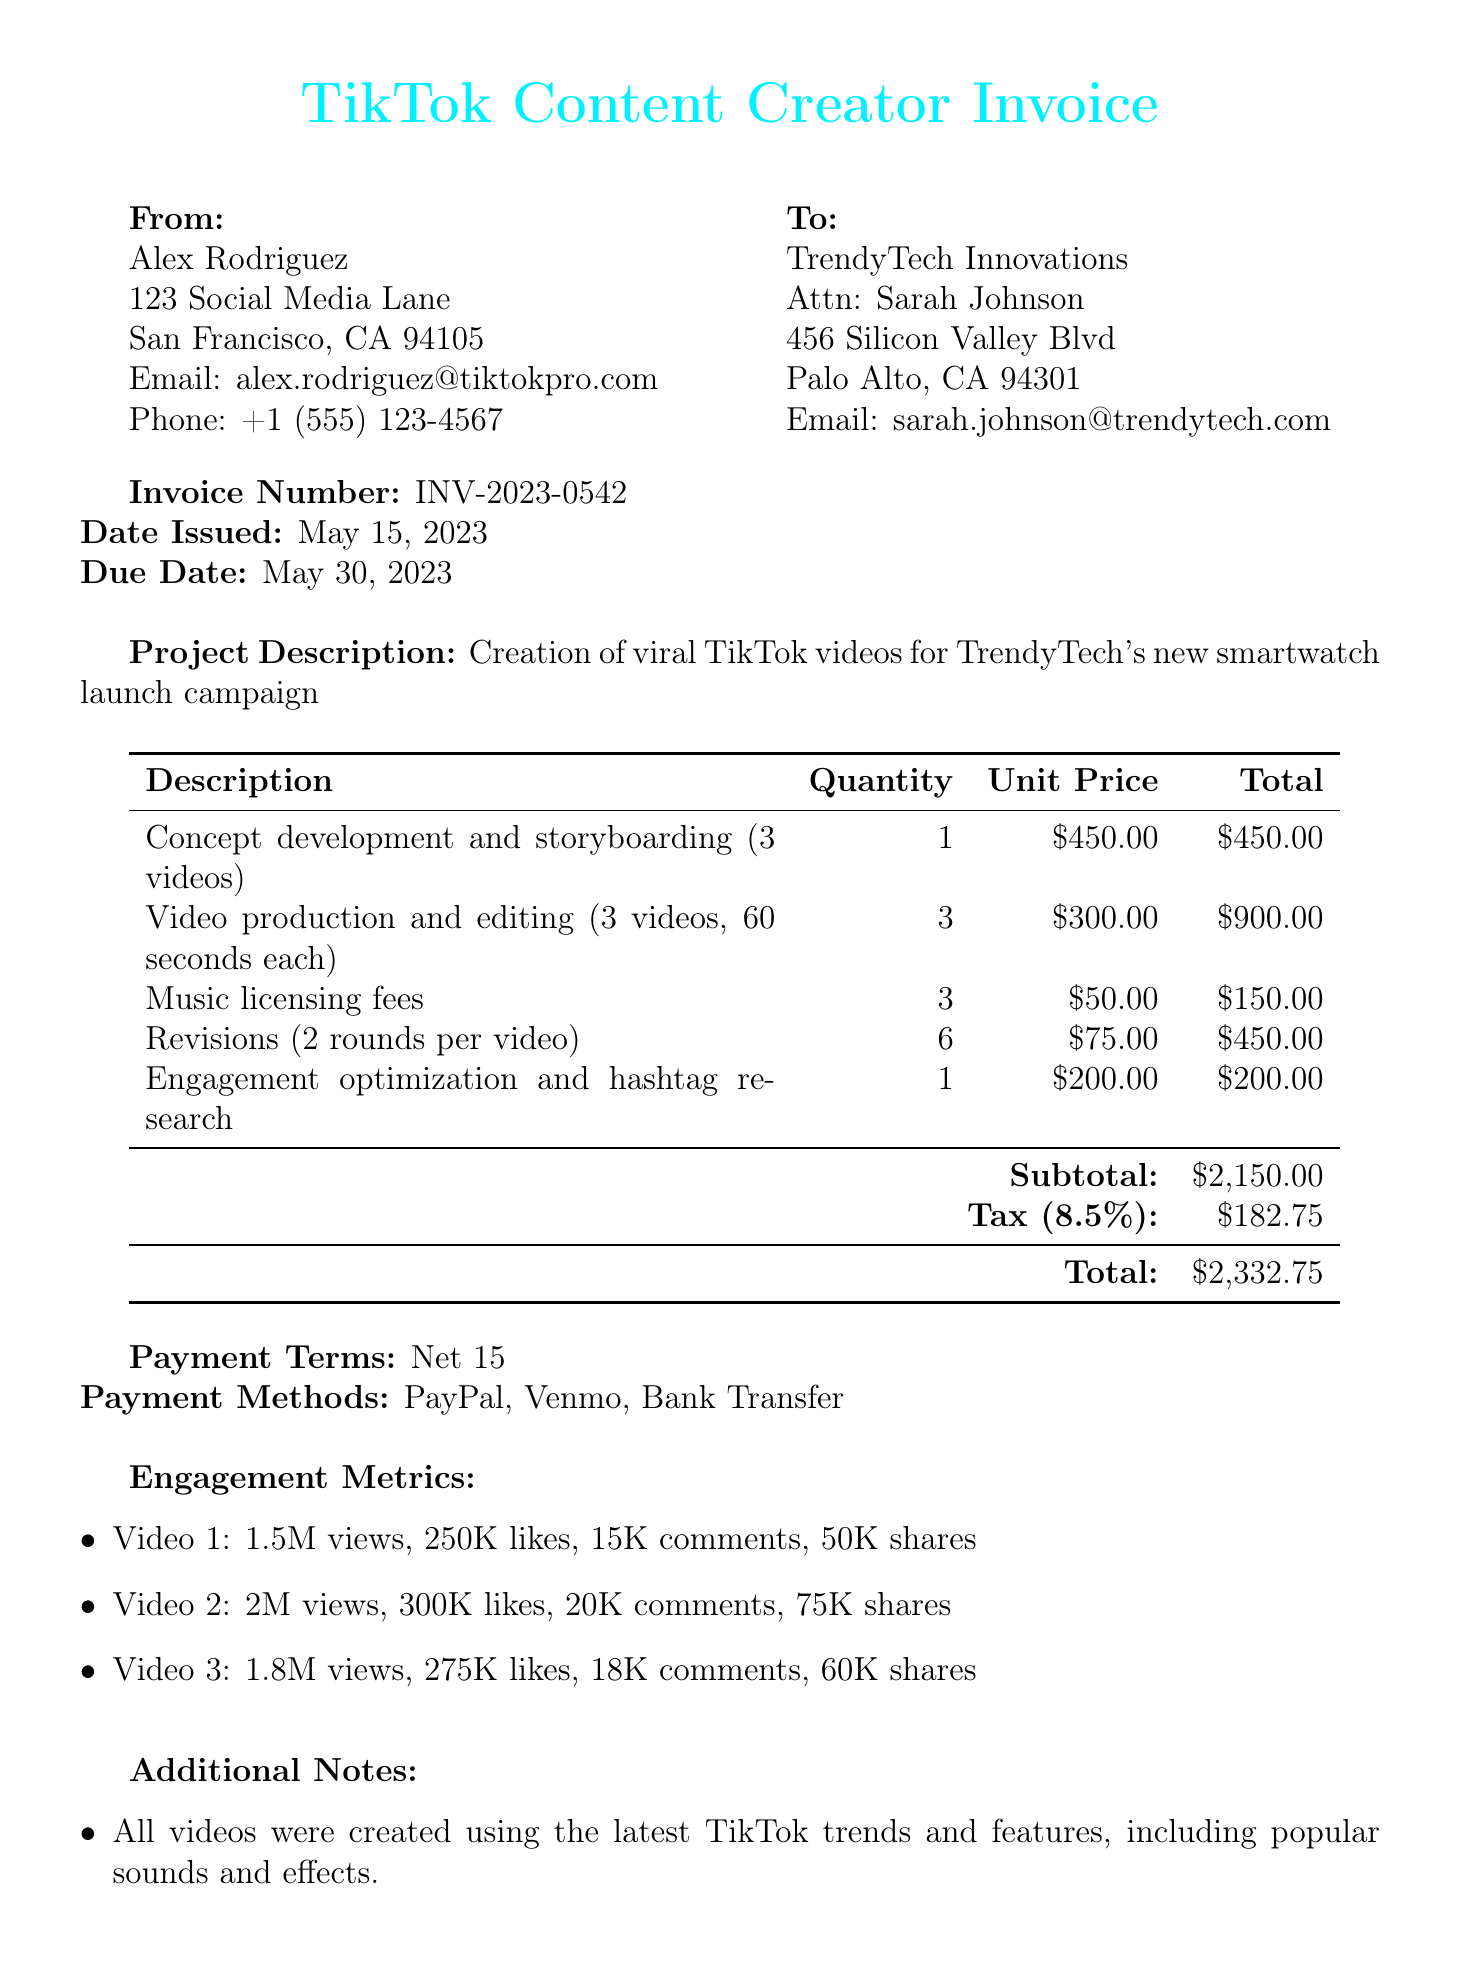What is the invoice number? The invoice number is a unique identifier for the document, which is listed as INV-2023-0542.
Answer: INV-2023-0542 Who is the freelancer? The freelancer's name is indicated in the document under freelancer details, which is Alex Rodriguez.
Answer: Alex Rodriguez What is the total amount due? The total amount due is calculated by adding the subtotal and tax amounts provided in the document, which totals to $2332.75.
Answer: $2332.75 How many videos were produced? The project involves the creation of three TikTok videos as described in the project details.
Answer: 3 videos What is the due date for the invoice? The due date is specified in the document as the date by which payment should be made, which is May 30, 2023.
Answer: May 30, 2023 What engagement metric has the highest count for video 2? The highest engagement metric for video 2 is the number of views, which is listed in the engagement metrics section.
Answer: 2M views What was included in the revisions? The revisions section details that there were 2 rounds of revisions per video for a total of 6 rounds.
Answer: 2 rounds per video What tools were used for video production? The document lists specific tools used, which include a TikTok Pro account, Adobe Premiere Pro, Canva Pro, and Epidemic Sound.
Answer: TikTok Pro account, Adobe Premiere Pro, Canva Pro, Epidemic Sound What is the payment term? The payment term specifies the duration within which the payment should be made, in this case, it states "Net 15."
Answer: Net 15 